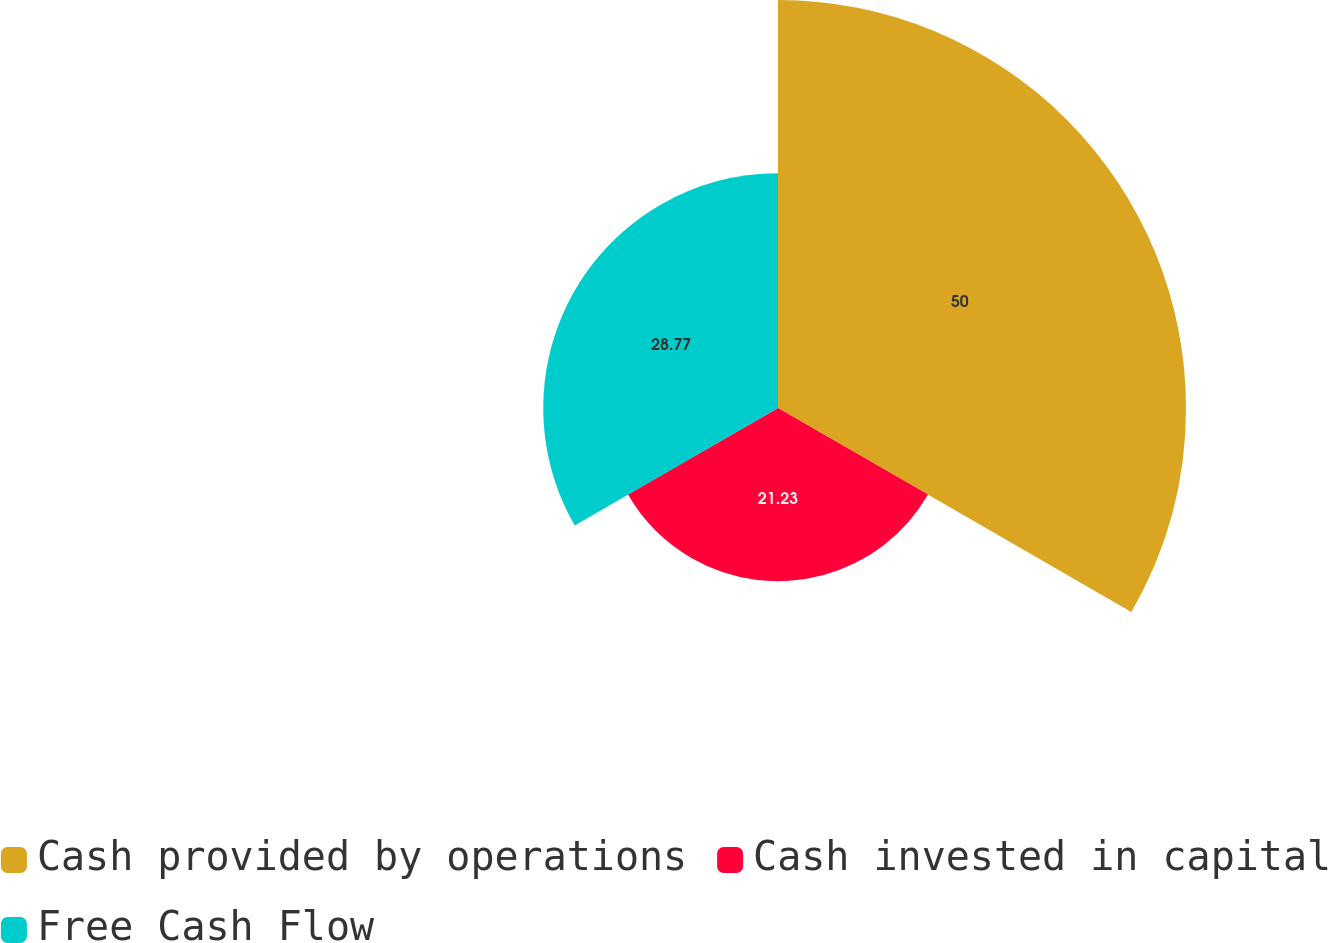<chart> <loc_0><loc_0><loc_500><loc_500><pie_chart><fcel>Cash provided by operations<fcel>Cash invested in capital<fcel>Free Cash Flow<nl><fcel>50.0%<fcel>21.23%<fcel>28.77%<nl></chart> 